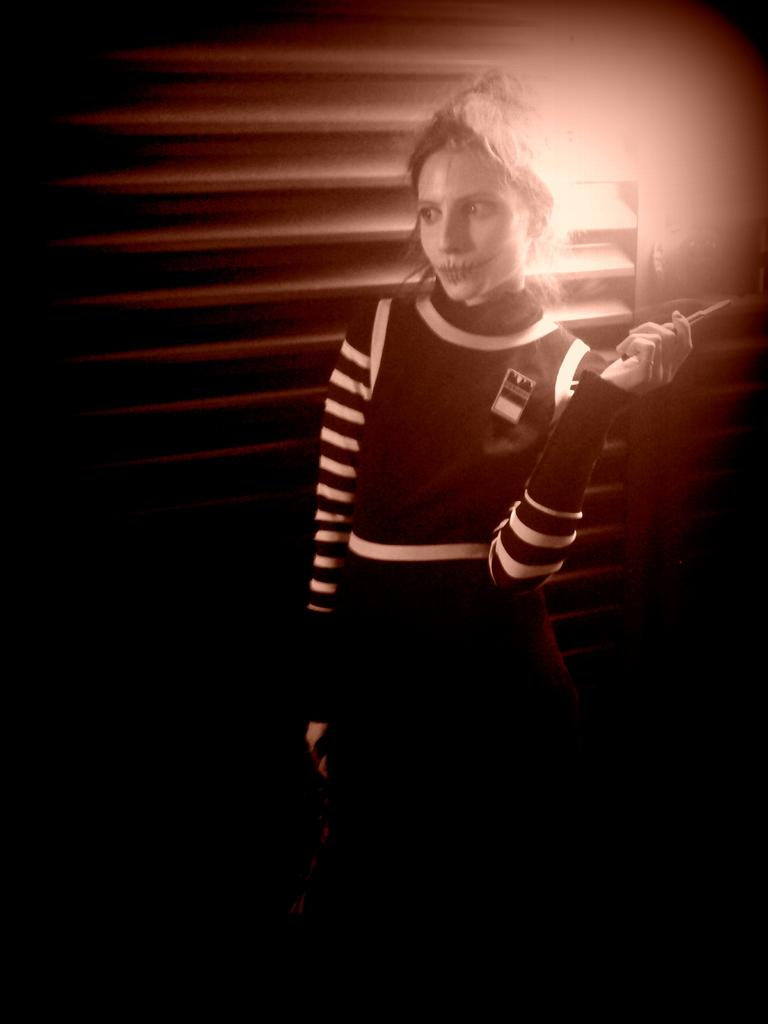Who is present in the image? There is a woman in the image. What is the woman standing near? The woman is standing near wooden blinds. What can be seen in the background of the image? There is a light beam visible in the background. How would you describe the lighting at the bottom of the image? The bottom of the image appears to be dark. What type of honey is being sold at the attraction in the image? There is no attraction or honey present in the image; it features a woman standing near wooden blinds with a light beam visible in the background. 